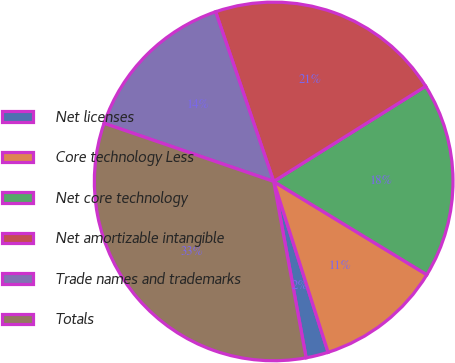<chart> <loc_0><loc_0><loc_500><loc_500><pie_chart><fcel>Net licenses<fcel>Core technology Less<fcel>Net core technology<fcel>Net amortizable intangible<fcel>Trade names and trademarks<fcel>Totals<nl><fcel>2.01%<fcel>11.39%<fcel>17.61%<fcel>21.34%<fcel>14.5%<fcel>33.15%<nl></chart> 